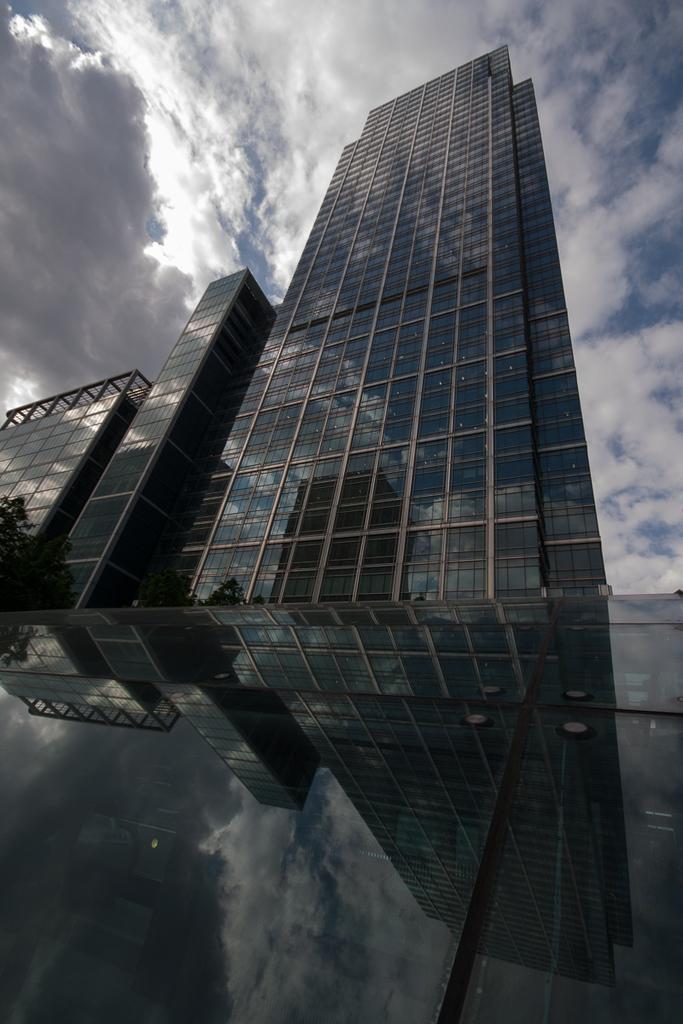Describe this image in one or two sentences. In this image I can see a building which is made up of glass, a tree and the glass surface in which I can see the reflection of a tree and the sky. In the background I can see the sky. 